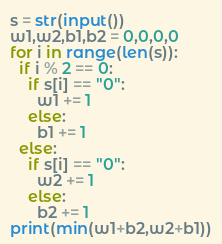Convert code to text. <code><loc_0><loc_0><loc_500><loc_500><_Python_>s = str(input())
w1,w2,b1,b2 = 0,0,0,0
for i in range(len(s)):
  if i % 2 == 0:
  	if s[i] == "0":
      w1 += 1
    else:
      b1 += 1
  else:
    if s[i] == "0":
      w2 += 1
    else:
      b2 += 1
print(min(w1+b2,w2+b1))</code> 